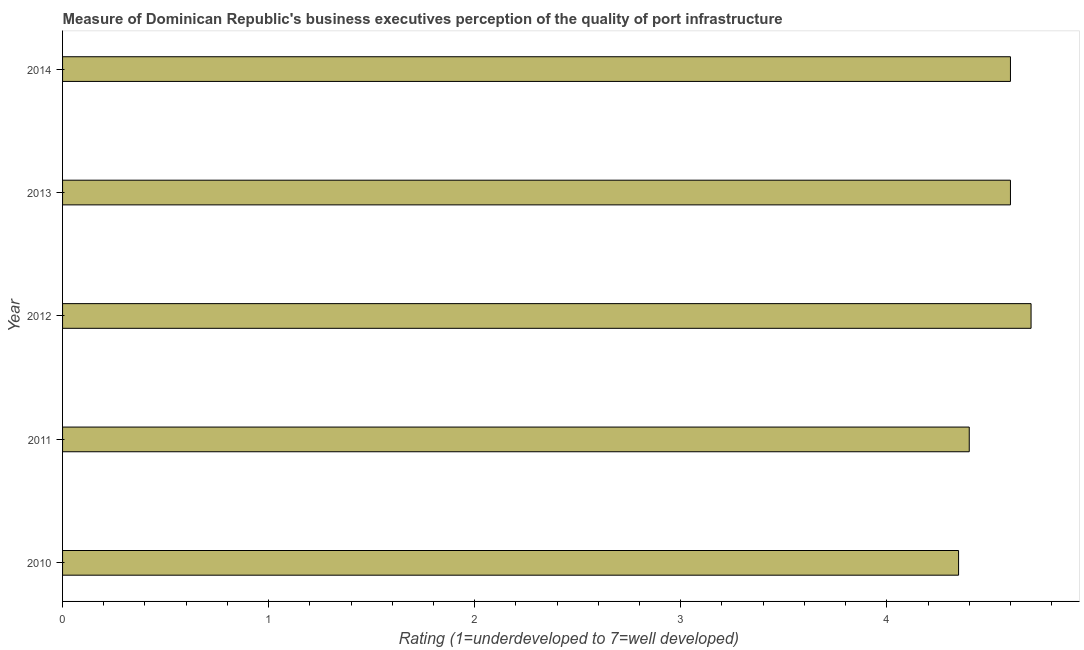What is the title of the graph?
Offer a terse response. Measure of Dominican Republic's business executives perception of the quality of port infrastructure. What is the label or title of the X-axis?
Your answer should be very brief. Rating (1=underdeveloped to 7=well developed) . What is the rating measuring quality of port infrastructure in 2010?
Give a very brief answer. 4.35. Across all years, what is the minimum rating measuring quality of port infrastructure?
Your answer should be very brief. 4.35. What is the sum of the rating measuring quality of port infrastructure?
Give a very brief answer. 22.65. What is the difference between the rating measuring quality of port infrastructure in 2010 and 2012?
Ensure brevity in your answer.  -0.35. What is the average rating measuring quality of port infrastructure per year?
Offer a very short reply. 4.53. In how many years, is the rating measuring quality of port infrastructure greater than 4 ?
Your answer should be compact. 5. Do a majority of the years between 2013 and 2012 (inclusive) have rating measuring quality of port infrastructure greater than 1.2 ?
Your answer should be compact. No. What is the ratio of the rating measuring quality of port infrastructure in 2010 to that in 2012?
Ensure brevity in your answer.  0.93. Is the rating measuring quality of port infrastructure in 2011 less than that in 2014?
Your response must be concise. Yes. Is the difference between the rating measuring quality of port infrastructure in 2012 and 2013 greater than the difference between any two years?
Your answer should be compact. No. What is the difference between the highest and the second highest rating measuring quality of port infrastructure?
Offer a terse response. 0.1. What is the difference between the highest and the lowest rating measuring quality of port infrastructure?
Give a very brief answer. 0.35. In how many years, is the rating measuring quality of port infrastructure greater than the average rating measuring quality of port infrastructure taken over all years?
Provide a short and direct response. 3. How many bars are there?
Give a very brief answer. 5. Are all the bars in the graph horizontal?
Provide a succinct answer. Yes. What is the difference between two consecutive major ticks on the X-axis?
Your answer should be very brief. 1. Are the values on the major ticks of X-axis written in scientific E-notation?
Give a very brief answer. No. What is the Rating (1=underdeveloped to 7=well developed)  in 2010?
Your response must be concise. 4.35. What is the Rating (1=underdeveloped to 7=well developed)  of 2013?
Your response must be concise. 4.6. What is the difference between the Rating (1=underdeveloped to 7=well developed)  in 2010 and 2011?
Your response must be concise. -0.05. What is the difference between the Rating (1=underdeveloped to 7=well developed)  in 2010 and 2012?
Your answer should be compact. -0.35. What is the difference between the Rating (1=underdeveloped to 7=well developed)  in 2010 and 2013?
Give a very brief answer. -0.25. What is the difference between the Rating (1=underdeveloped to 7=well developed)  in 2010 and 2014?
Your answer should be compact. -0.25. What is the difference between the Rating (1=underdeveloped to 7=well developed)  in 2011 and 2013?
Your answer should be compact. -0.2. What is the difference between the Rating (1=underdeveloped to 7=well developed)  in 2011 and 2014?
Your answer should be compact. -0.2. What is the difference between the Rating (1=underdeveloped to 7=well developed)  in 2012 and 2013?
Provide a succinct answer. 0.1. What is the difference between the Rating (1=underdeveloped to 7=well developed)  in 2012 and 2014?
Provide a succinct answer. 0.1. What is the difference between the Rating (1=underdeveloped to 7=well developed)  in 2013 and 2014?
Your answer should be compact. 0. What is the ratio of the Rating (1=underdeveloped to 7=well developed)  in 2010 to that in 2012?
Provide a succinct answer. 0.93. What is the ratio of the Rating (1=underdeveloped to 7=well developed)  in 2010 to that in 2013?
Your answer should be very brief. 0.94. What is the ratio of the Rating (1=underdeveloped to 7=well developed)  in 2010 to that in 2014?
Your answer should be compact. 0.94. What is the ratio of the Rating (1=underdeveloped to 7=well developed)  in 2011 to that in 2012?
Give a very brief answer. 0.94. What is the ratio of the Rating (1=underdeveloped to 7=well developed)  in 2011 to that in 2014?
Give a very brief answer. 0.96. What is the ratio of the Rating (1=underdeveloped to 7=well developed)  in 2012 to that in 2013?
Keep it short and to the point. 1.02. What is the ratio of the Rating (1=underdeveloped to 7=well developed)  in 2012 to that in 2014?
Provide a short and direct response. 1.02. What is the ratio of the Rating (1=underdeveloped to 7=well developed)  in 2013 to that in 2014?
Your response must be concise. 1. 